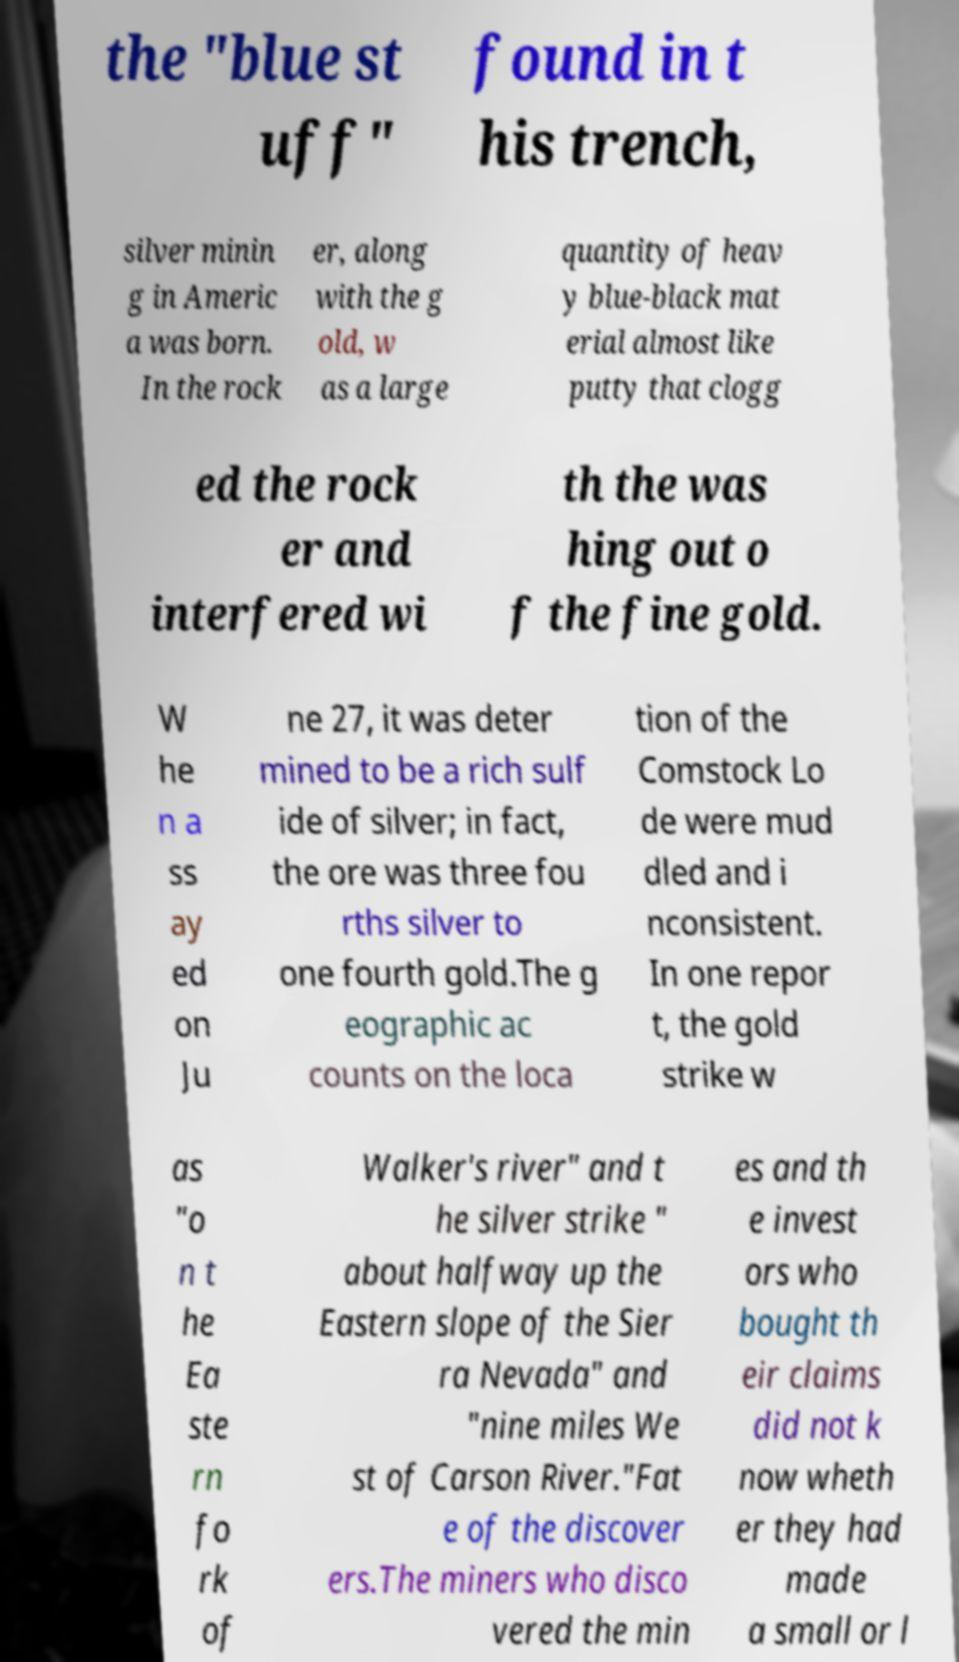There's text embedded in this image that I need extracted. Can you transcribe it verbatim? the "blue st uff" found in t his trench, silver minin g in Americ a was born. In the rock er, along with the g old, w as a large quantity of heav y blue-black mat erial almost like putty that clogg ed the rock er and interfered wi th the was hing out o f the fine gold. W he n a ss ay ed on Ju ne 27, it was deter mined to be a rich sulf ide of silver; in fact, the ore was three fou rths silver to one fourth gold.The g eographic ac counts on the loca tion of the Comstock Lo de were mud dled and i nconsistent. In one repor t, the gold strike w as "o n t he Ea ste rn fo rk of Walker's river" and t he silver strike " about halfway up the Eastern slope of the Sier ra Nevada" and "nine miles We st of Carson River."Fat e of the discover ers.The miners who disco vered the min es and th e invest ors who bought th eir claims did not k now wheth er they had made a small or l 